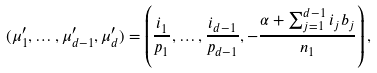Convert formula to latex. <formula><loc_0><loc_0><loc_500><loc_500>( \mu ^ { \prime } _ { 1 } , \dots , \mu ^ { \prime } _ { d - 1 } , \mu ^ { \prime } _ { d } ) = \left ( \frac { i _ { 1 } } { p _ { 1 } } , \dots , \frac { i _ { d - 1 } } { p _ { d - 1 } } , - \frac { \alpha + \sum _ { j = 1 } ^ { d - 1 } i _ { j } b _ { j } } { n _ { 1 } } \right ) ,</formula> 